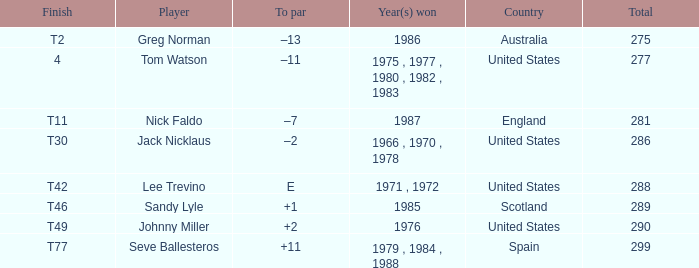What country had a finish of t49? United States. 